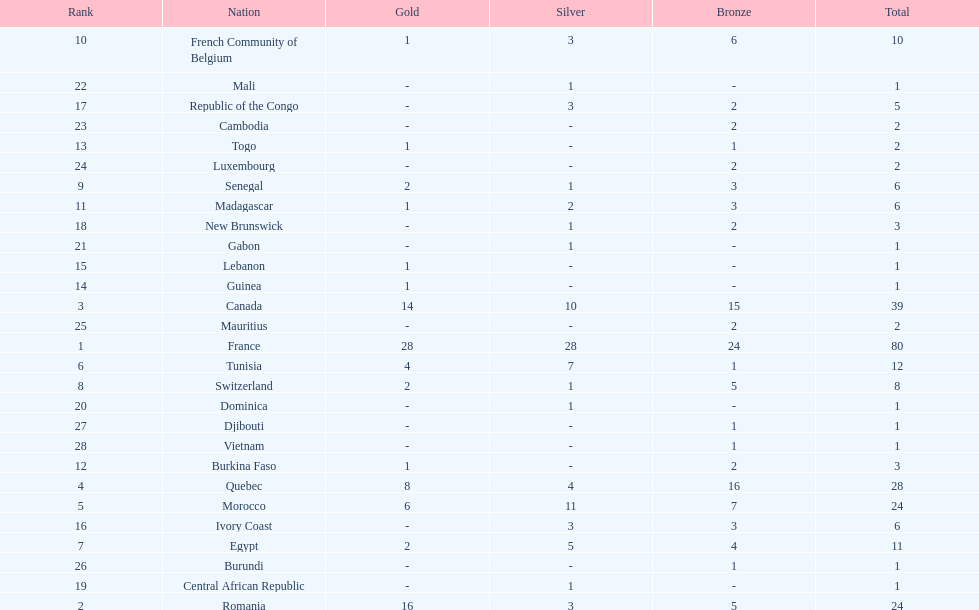Parse the table in full. {'header': ['Rank', 'Nation', 'Gold', 'Silver', 'Bronze', 'Total'], 'rows': [['10', 'French Community of Belgium', '1', '3', '6', '10'], ['22', 'Mali', '-', '1', '-', '1'], ['17', 'Republic of the Congo', '-', '3', '2', '5'], ['23', 'Cambodia', '-', '-', '2', '2'], ['13', 'Togo', '1', '-', '1', '2'], ['24', 'Luxembourg', '-', '-', '2', '2'], ['9', 'Senegal', '2', '1', '3', '6'], ['11', 'Madagascar', '1', '2', '3', '6'], ['18', 'New Brunswick', '-', '1', '2', '3'], ['21', 'Gabon', '-', '1', '-', '1'], ['15', 'Lebanon', '1', '-', '-', '1'], ['14', 'Guinea', '1', '-', '-', '1'], ['3', 'Canada', '14', '10', '15', '39'], ['25', 'Mauritius', '-', '-', '2', '2'], ['1', 'France', '28', '28', '24', '80'], ['6', 'Tunisia', '4', '7', '1', '12'], ['8', 'Switzerland', '2', '1', '5', '8'], ['20', 'Dominica', '-', '1', '-', '1'], ['27', 'Djibouti', '-', '-', '1', '1'], ['28', 'Vietnam', '-', '-', '1', '1'], ['12', 'Burkina Faso', '1', '-', '2', '3'], ['4', 'Quebec', '8', '4', '16', '28'], ['5', 'Morocco', '6', '11', '7', '24'], ['16', 'Ivory Coast', '-', '3', '3', '6'], ['7', 'Egypt', '2', '5', '4', '11'], ['26', 'Burundi', '-', '-', '1', '1'], ['19', 'Central African Republic', '-', '1', '-', '1'], ['2', 'Romania', '16', '3', '5', '24']]} What was the total medal count of switzerland? 8. 